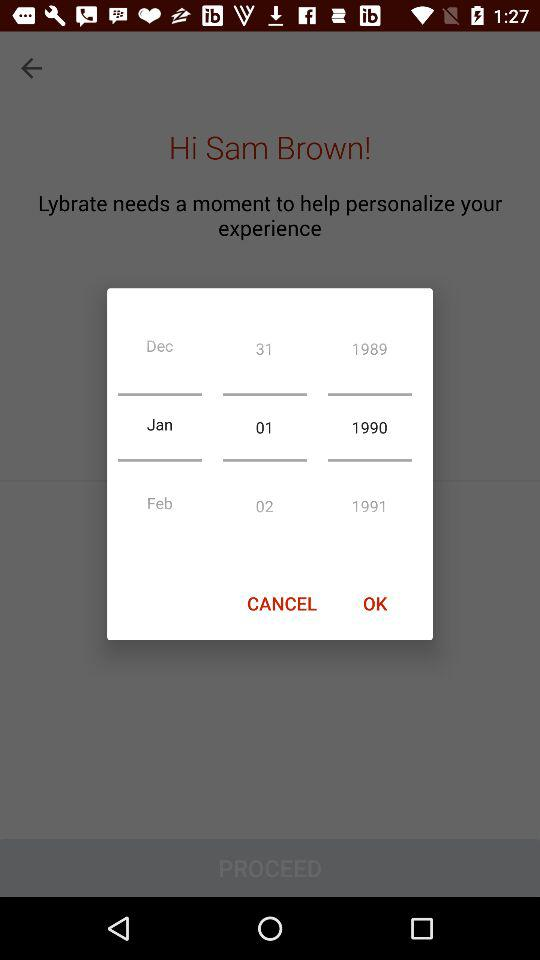What is the selected date? The selected date is January 1, 1990. 